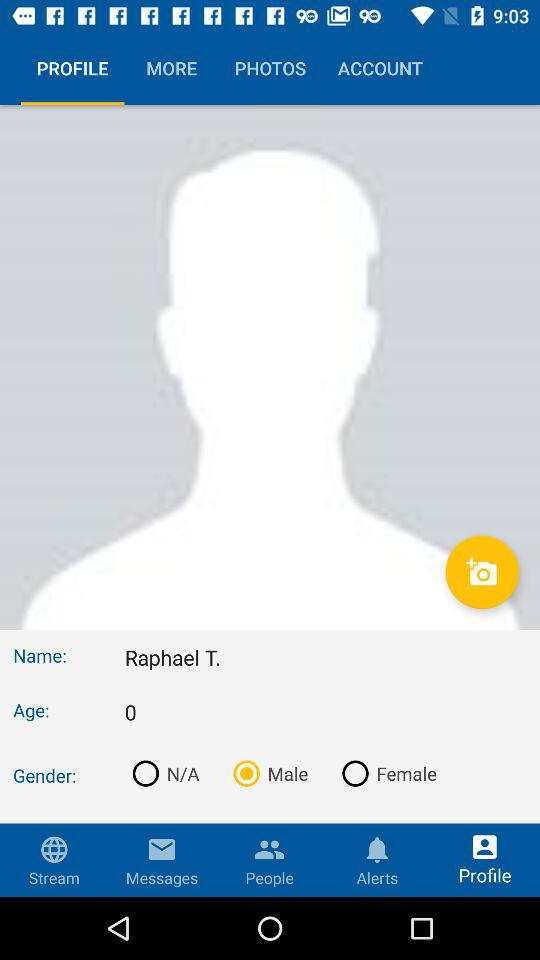What is the name? The name is "Raphael T.". 